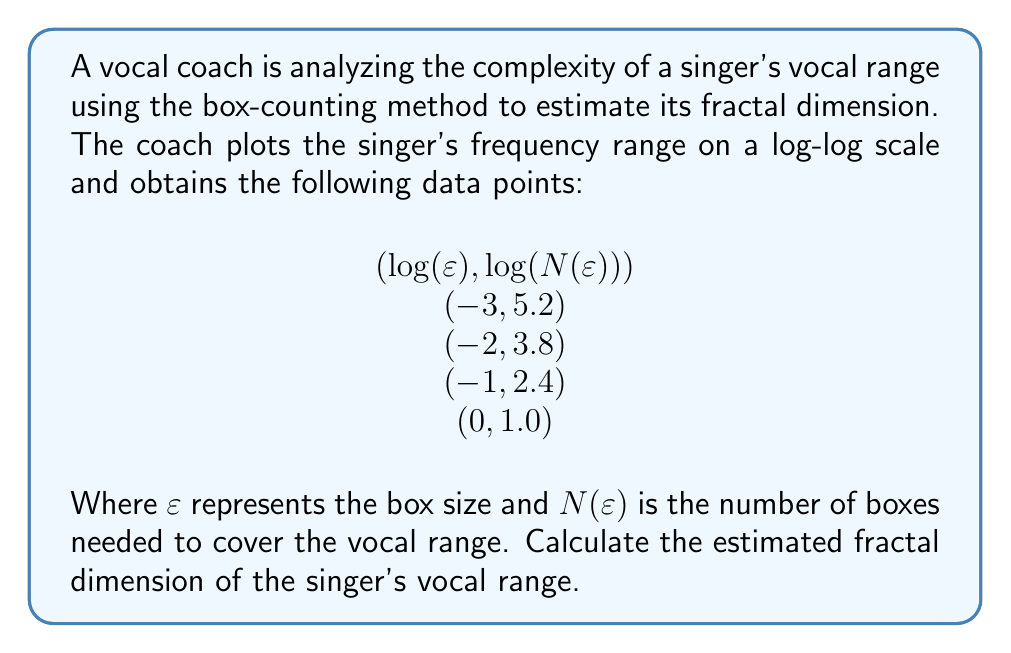Give your solution to this math problem. To estimate the fractal dimension using the box-counting method, we need to follow these steps:

1) The fractal dimension D is given by the slope of the log-log plot of N(ε) vs ε.

2) We can calculate the slope using the formula:

   $$D = -\lim_{\varepsilon \to 0} \frac{\log N(\varepsilon)}{\log \varepsilon}$$

3) In practice, we estimate this by calculating the slope of the best-fit line through our data points.

4) We can use the least squares method to find the slope. The formula for the slope m is:

   $$m = \frac{n\sum(xy) - \sum x \sum y}{n\sum x^2 - (\sum x)^2}$$

   where x = log(ε) and y = log(N(ε))

5) Let's calculate the necessary sums:
   
   $$\sum x = -3 - 2 - 1 + 0 = -6$$
   $$\sum y = 5.2 + 3.8 + 2.4 + 1.0 = 12.4$$
   $$\sum xy = (-3)(5.2) + (-2)(3.8) + (-1)(2.4) + (0)(1.0) = -23.8$$
   $$\sum x^2 = (-3)^2 + (-2)^2 + (-1)^2 + 0^2 = 14$$
   $$n = 4$$ (number of data points)

6) Plugging these values into the slope formula:

   $$m = \frac{4(-23.8) - (-6)(12.4)}{4(14) - (-6)^2} = \frac{-95.2 - (-74.4)}{56 - 36} = \frac{-20.8}{20} = -1.04$$

7) The fractal dimension D is the negative of this slope:

   $$D = -(-1.04) = 1.04$$

Thus, the estimated fractal dimension of the singer's vocal range is 1.04.
Answer: 1.04 